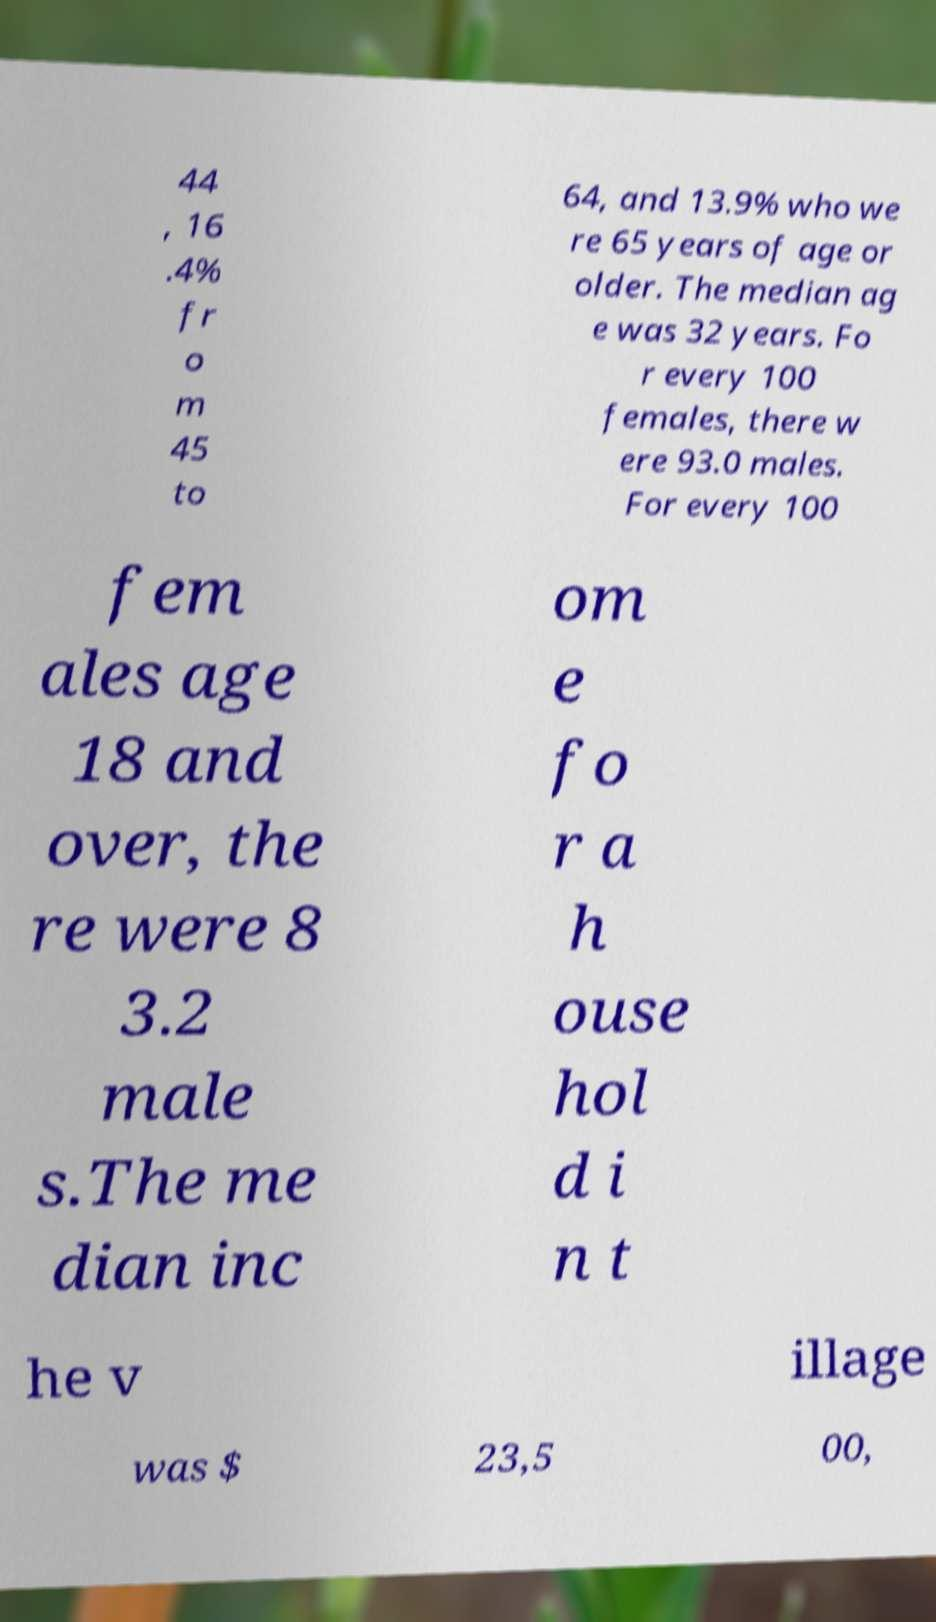I need the written content from this picture converted into text. Can you do that? 44 , 16 .4% fr o m 45 to 64, and 13.9% who we re 65 years of age or older. The median ag e was 32 years. Fo r every 100 females, there w ere 93.0 males. For every 100 fem ales age 18 and over, the re were 8 3.2 male s.The me dian inc om e fo r a h ouse hol d i n t he v illage was $ 23,5 00, 